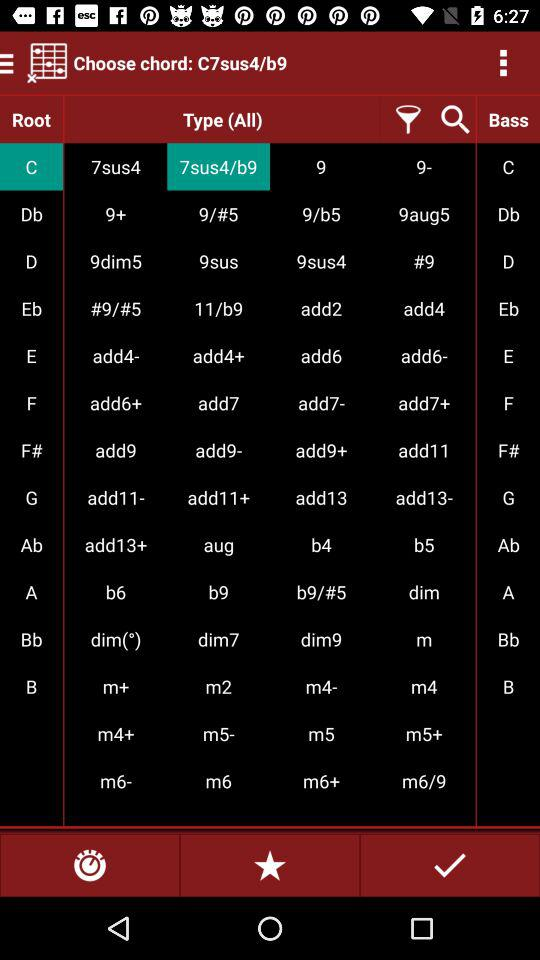Which "Type (All)" chords is selected? The selected "Type (All)" chords are "7sus4/b9". 